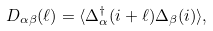<formula> <loc_0><loc_0><loc_500><loc_500>D _ { \alpha \beta } ( \ell ) = \langle \Delta _ { \alpha } ^ { \dag } ( i + \ell ) \Delta _ { \beta } ( i ) \rangle ,</formula> 